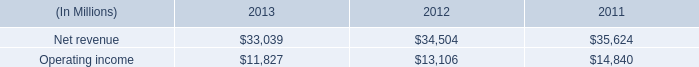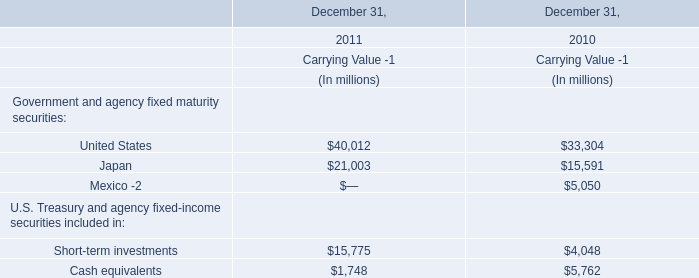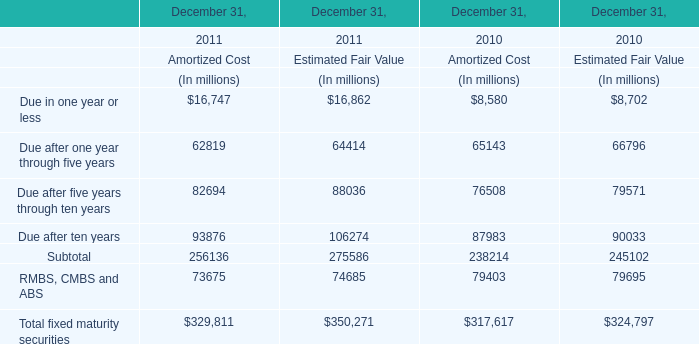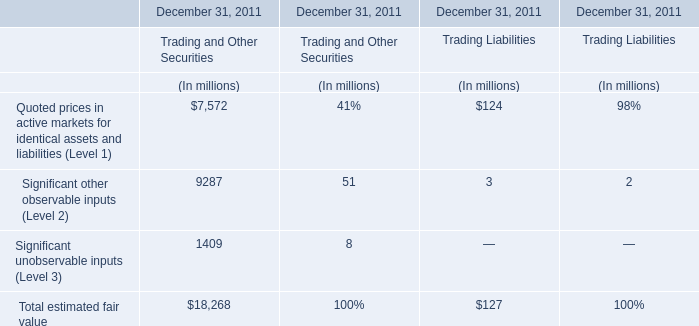What was the total amount of United States greater than 1 in Carrying value-1? 
Computations: (40012 + 33304)
Answer: 73316.0. 